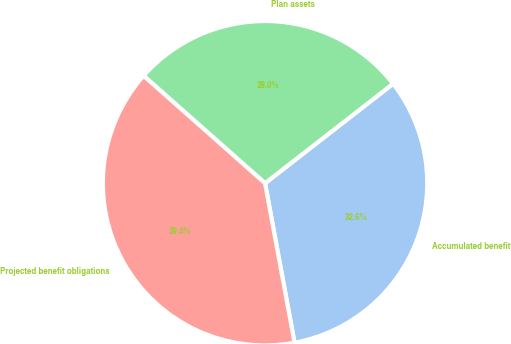Convert chart. <chart><loc_0><loc_0><loc_500><loc_500><pie_chart><fcel>Accumulated benefit<fcel>Plan assets<fcel>Projected benefit obligations<nl><fcel>32.6%<fcel>27.96%<fcel>39.44%<nl></chart> 